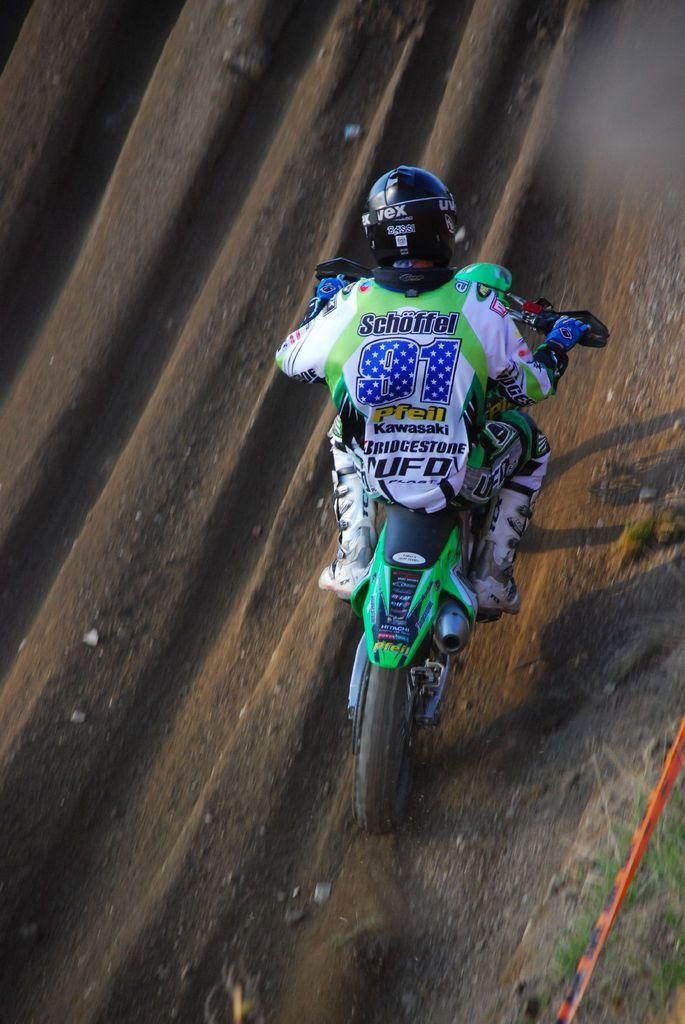Who is present in the image? There is a person in the image. What protective gear is the person wearing? The person is wearing a helmet and gloves. What mode of transportation is the person using? The person is riding a motorcycle. What type of terrain can be seen in the image? There is soil on the ground in the image. What scent is emanating from the coach in the image? There is no coach present in the image, and therefore no scent can be attributed to it. 